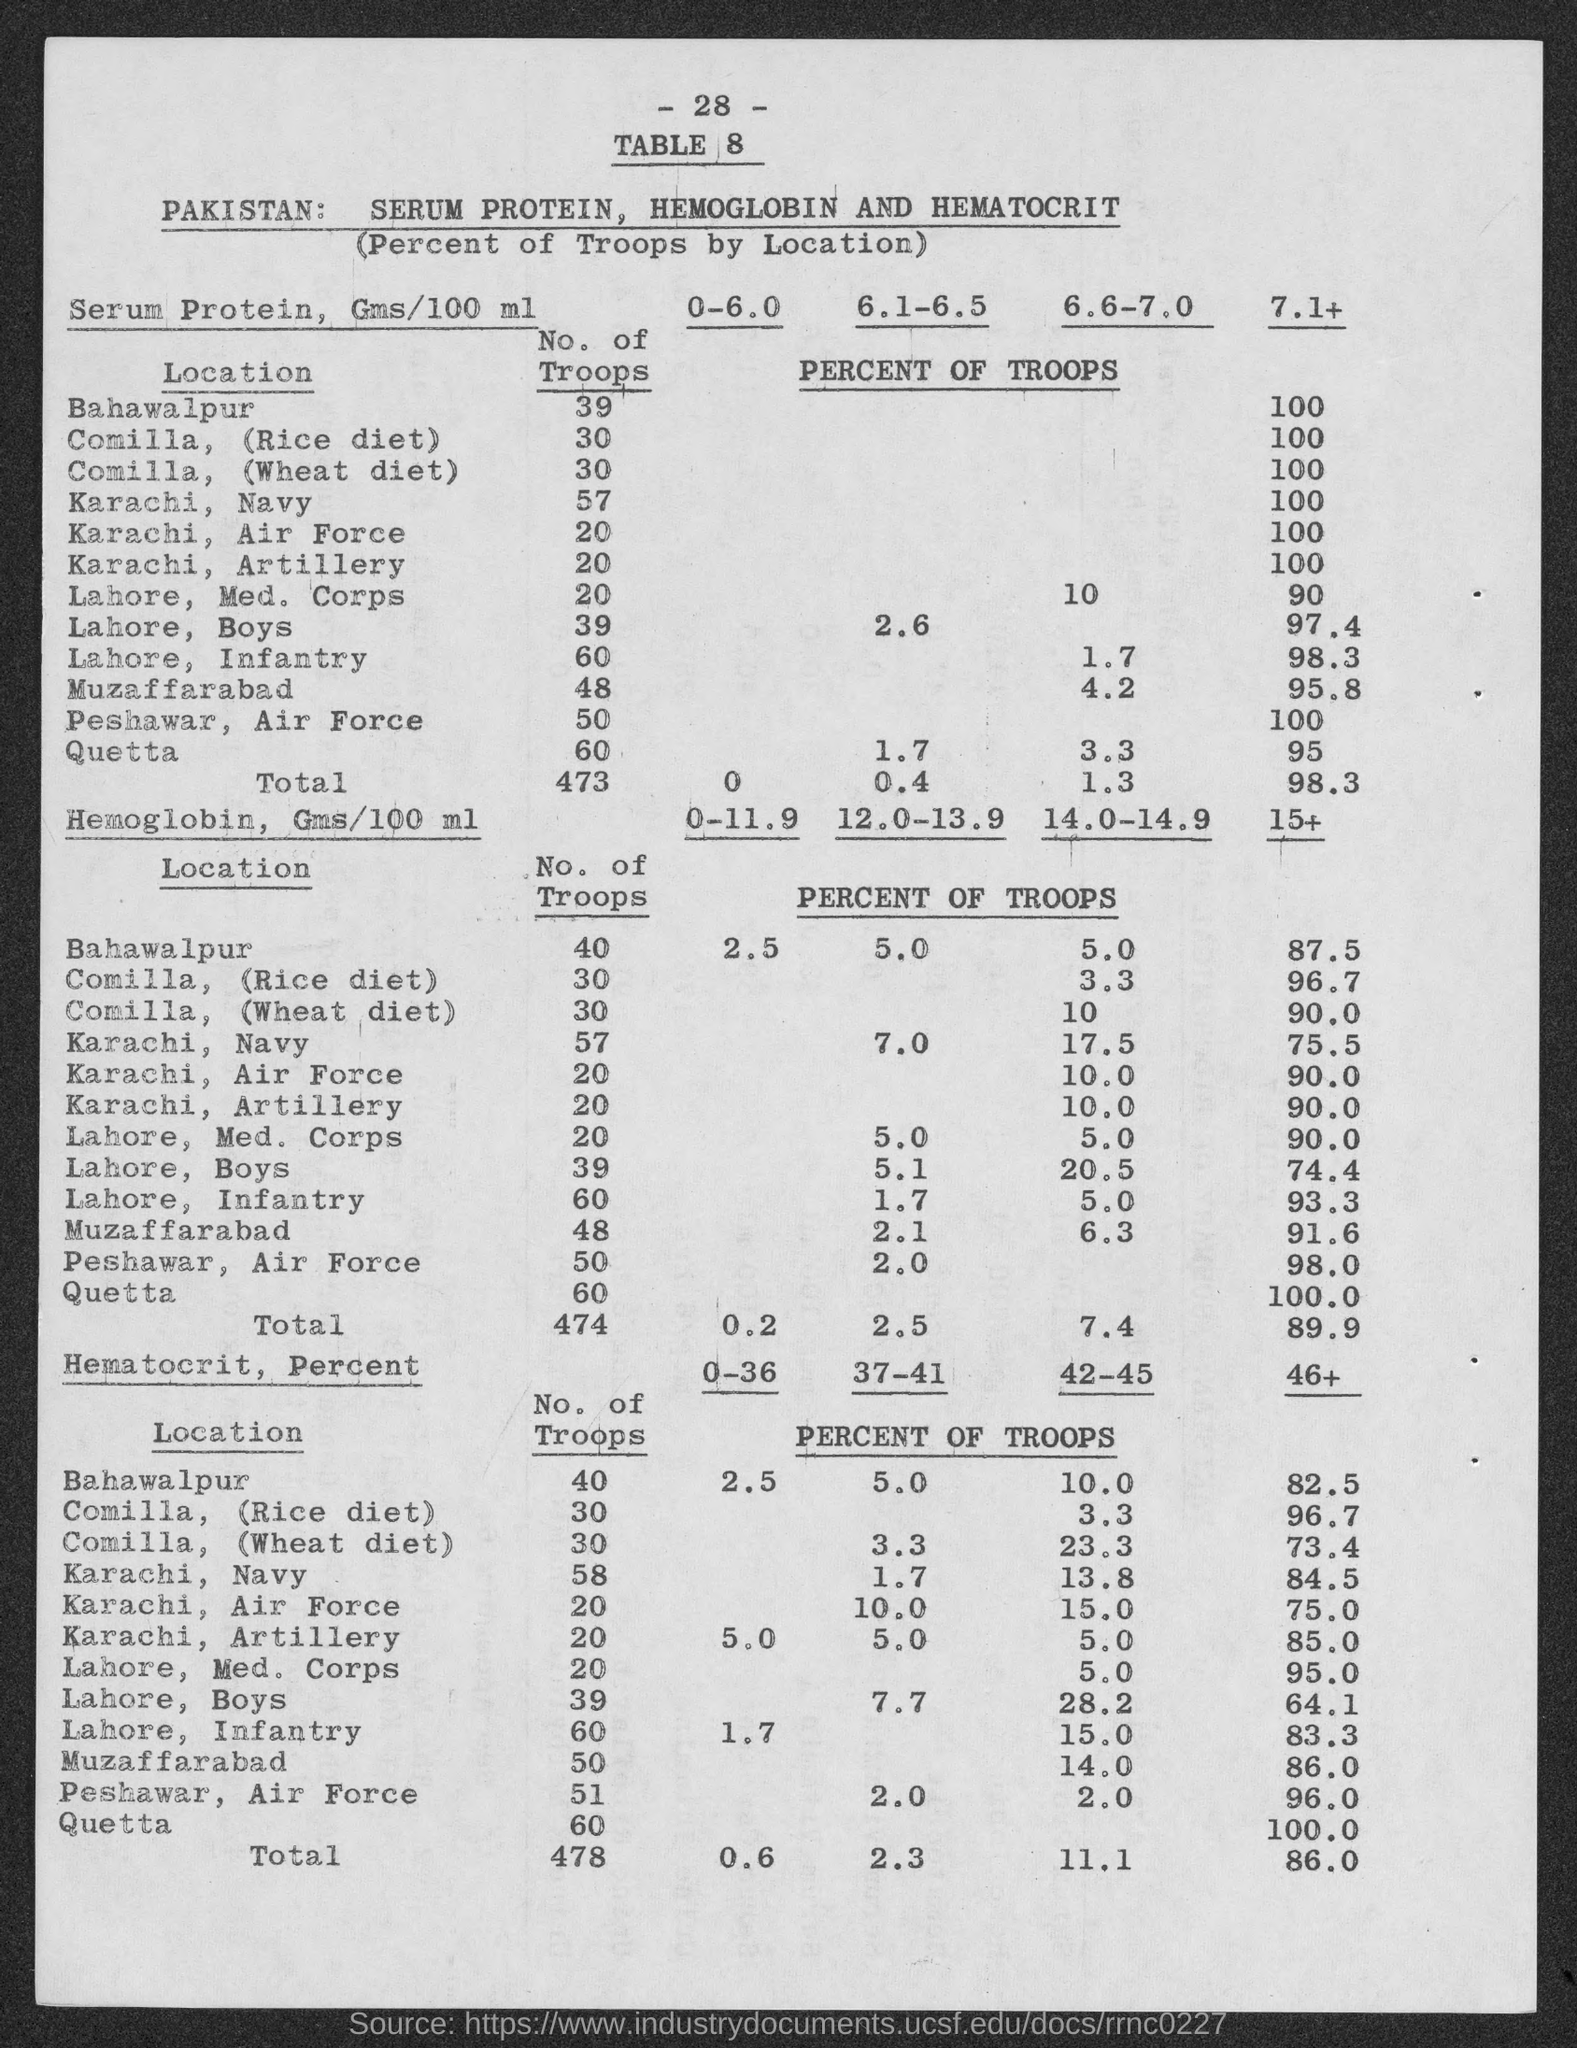Indicate a few pertinent items in this graphic. The total number of troops for serum protein is 473. The page number of the table is 28. 